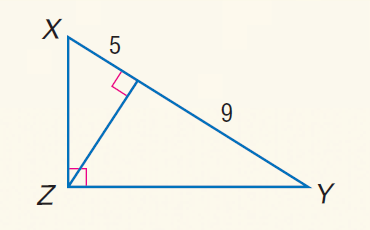Question: Find the measure of the altitude drawn to the hypotenuse.
Choices:
A. \sqrt { 3 }
B. \sqrt { 5 }
C. 3
D. 3 \sqrt { 5 }
Answer with the letter. Answer: D 